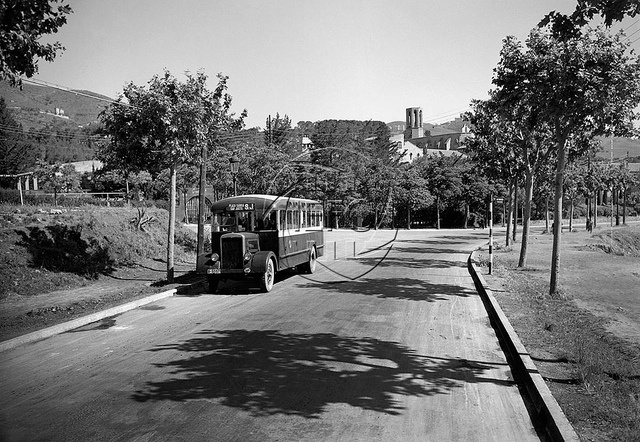Describe the objects in this image and their specific colors. I can see bus in black, gray, darkgray, and lightgray tones in this image. 